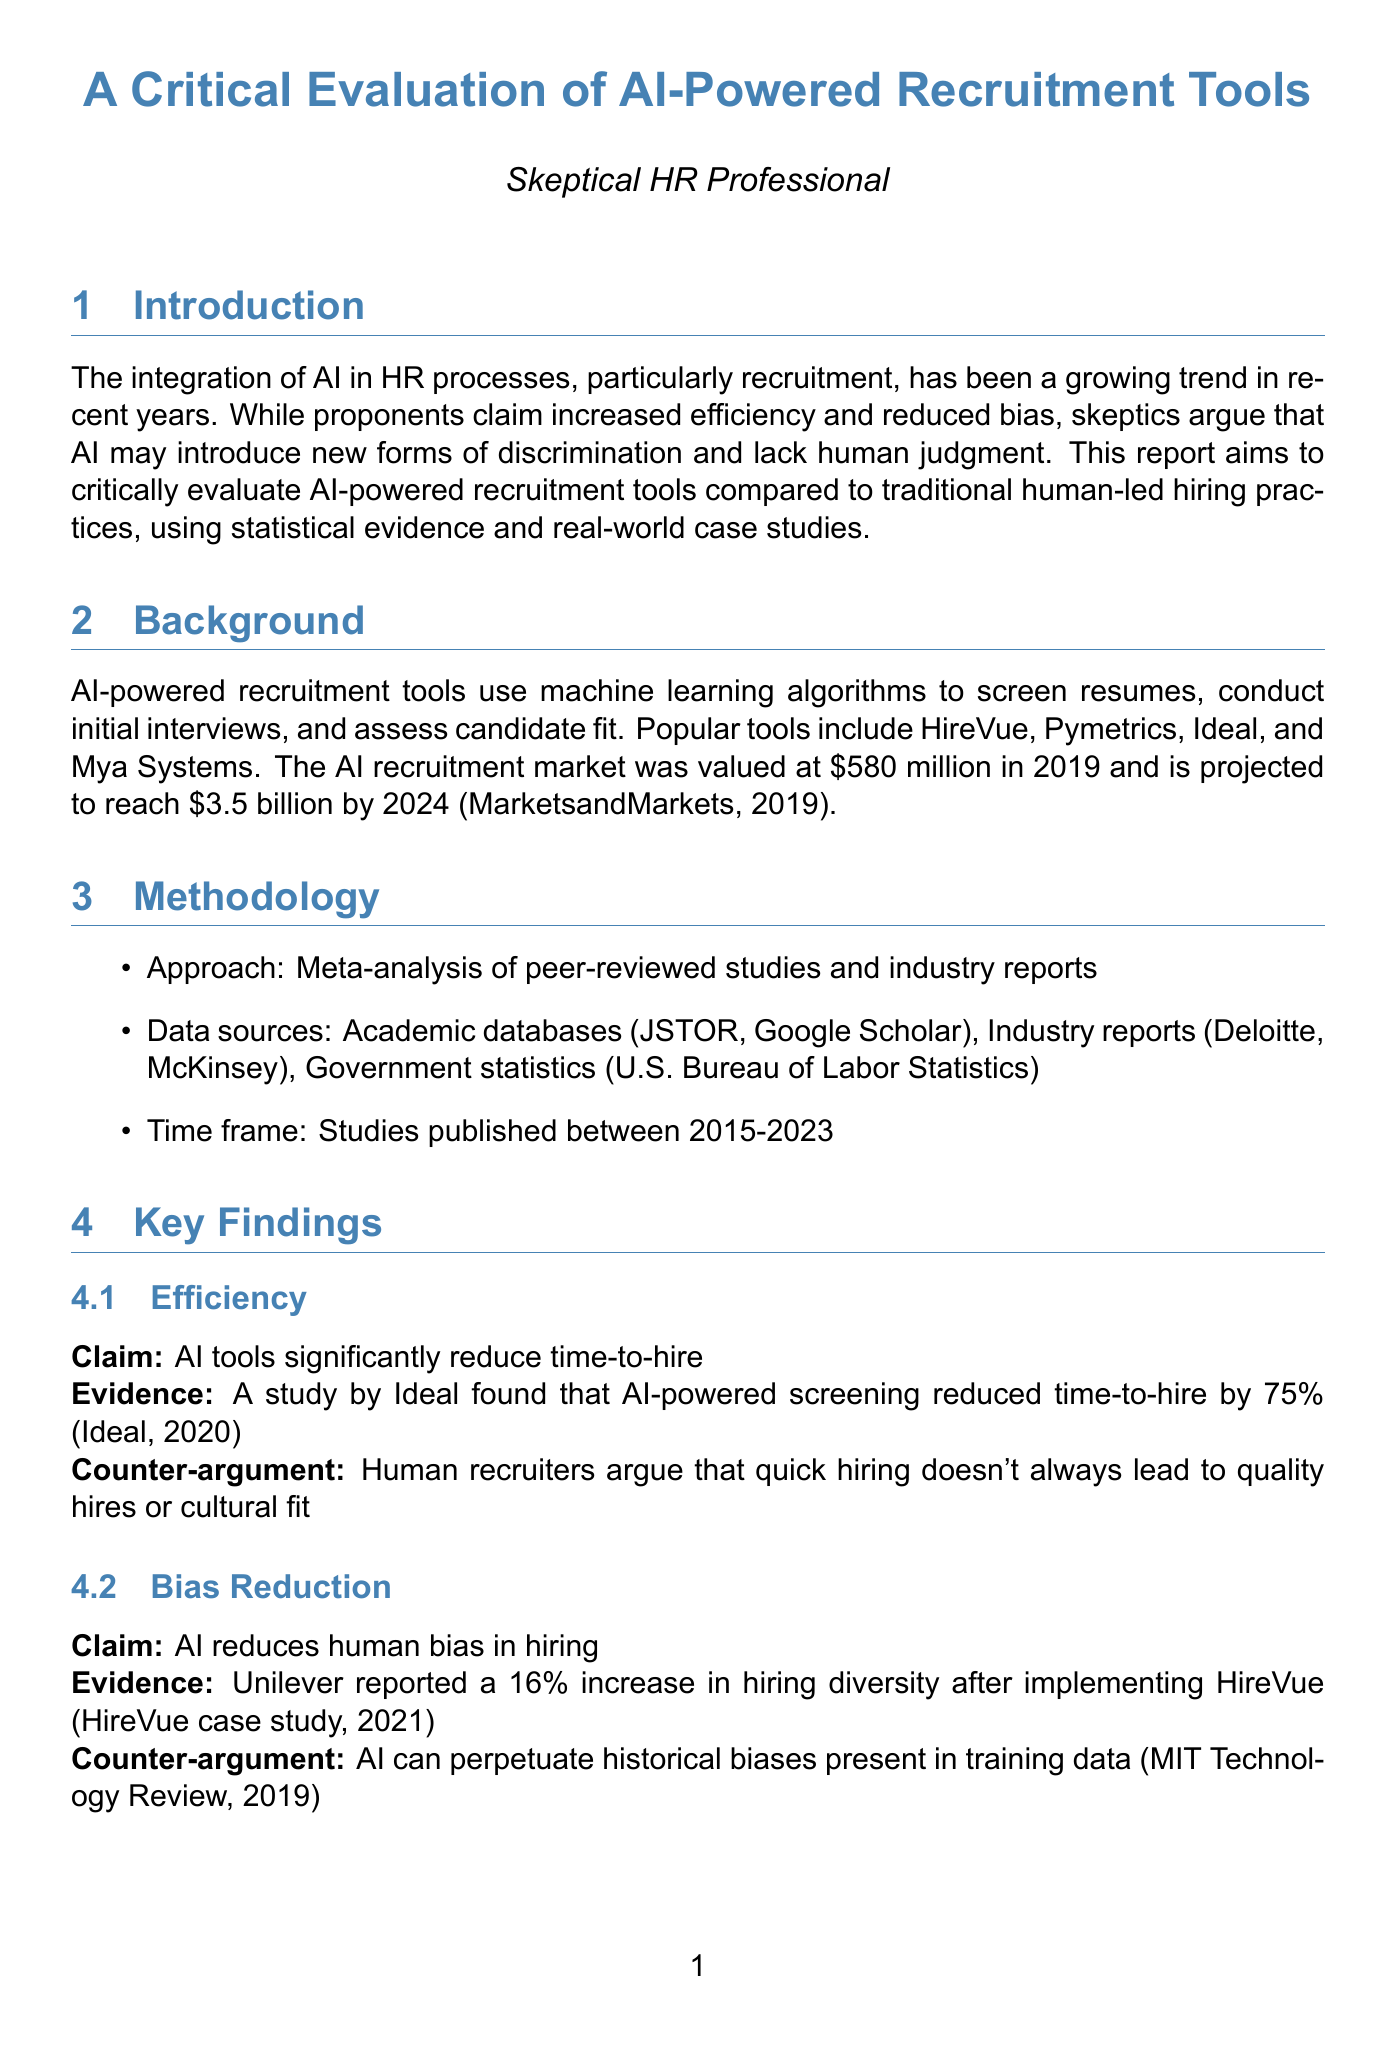what is the projected market size of AI in recruitment by 2024? The document states that the AI recruitment market is projected to reach $3.5 billion by 2024.
Answer: $3.5 billion which company reported a 16% increase in hiring diversity? The report mentions that Unilever reported this increase after implementing HireVue.
Answer: Unilever what was the retention rate for AI-powered recruitment tools? The document provides that the retention rate for AI-powered tools is 76%.
Answer: 76% what lesson was learned from Amazon's case study? The outcome of Amazon's scenario highlights the importance of diverse training data and human oversight in AI systems.
Answer: Importance of diverse training data and human oversight who is the president of the WZB Berlin Social Science Center? The report cites Dr. Jutta Allmendinger as the president.
Answer: Dr. Jutta Allmendinger what is the initial claim regarding AI tools and recruitment costs? The report claims that AI reduces recruitment costs.
Answer: AI reduces recruitment costs how much time-to-hire was reduced by Vodafone's implementation of HireVue? Vodafone achieved a 50% reduction in time-to-hire by implementing HireVue according to the case study.
Answer: 50% what percentage of candidates found AI interviews impersonal? The document states that 36% of candidates found AI interviews to be impersonal and frustrating.
Answer: 36% 